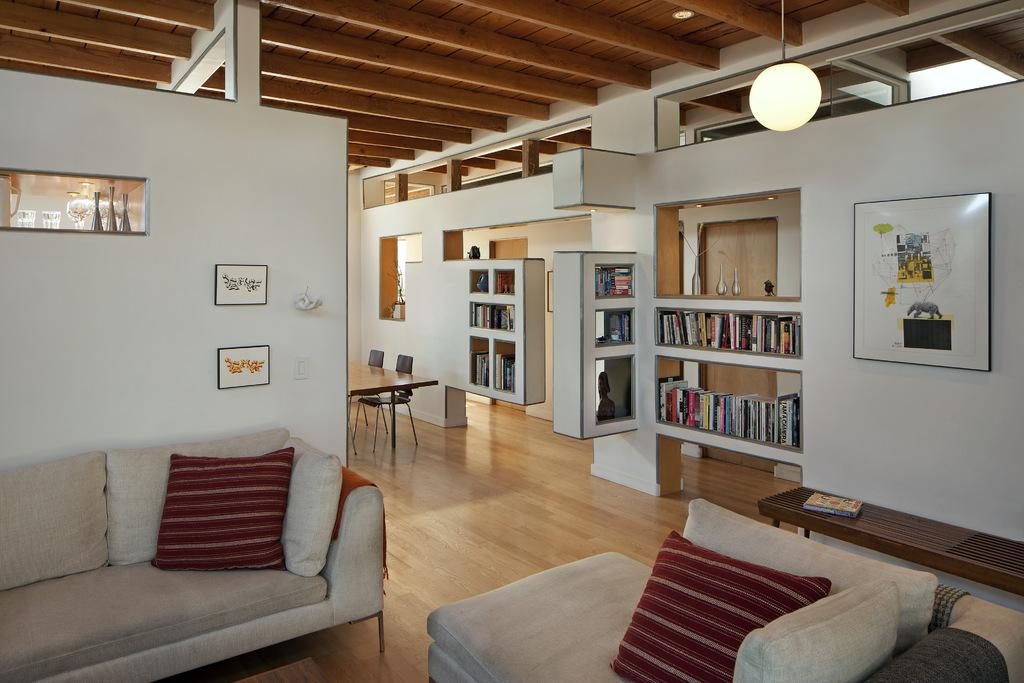What type of furniture is in the image? There is a couch in the image. What can be seen on the couch? There are pillows in the image. What is stored on the shelves in the image? There are books in the shelves in the image. What type of decorations are attached to the wall in the image? There are paintings attached to the wall in the image. What provides illumination in the image? There is a light in the image. What type of table is in the image? There is a dining table in the image. Can you see a bat flying around in the image? There is no bat present in the image. Is there a beast swimming in the dining table in the image? There is no beast or swimming activity depicted in the image. 